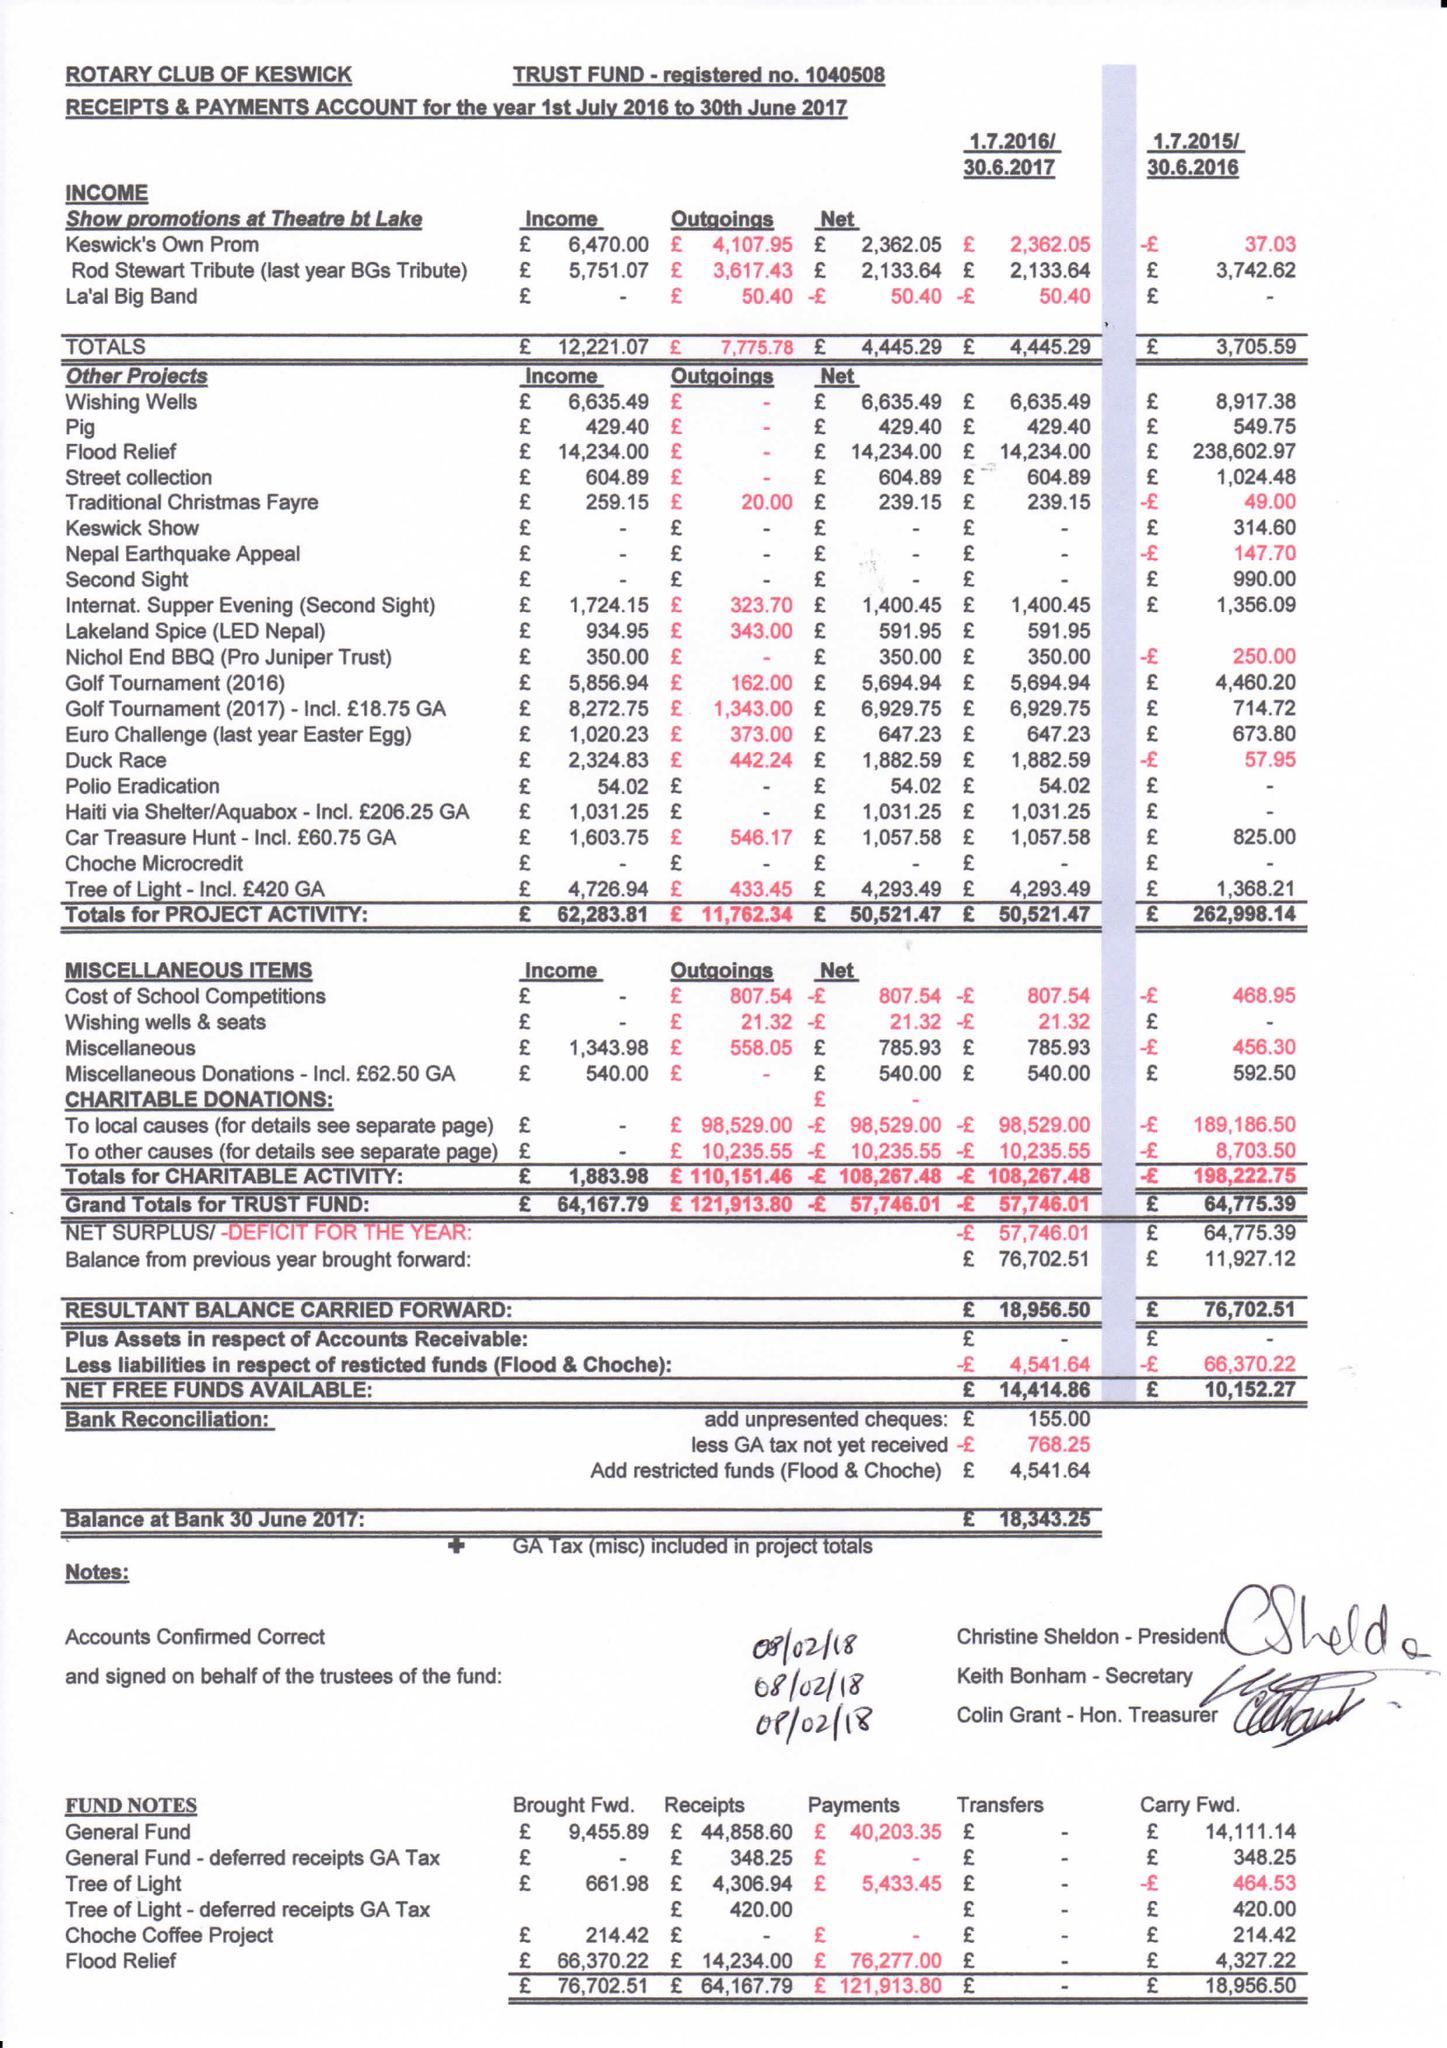What is the value for the report_date?
Answer the question using a single word or phrase. 2017-06-30 